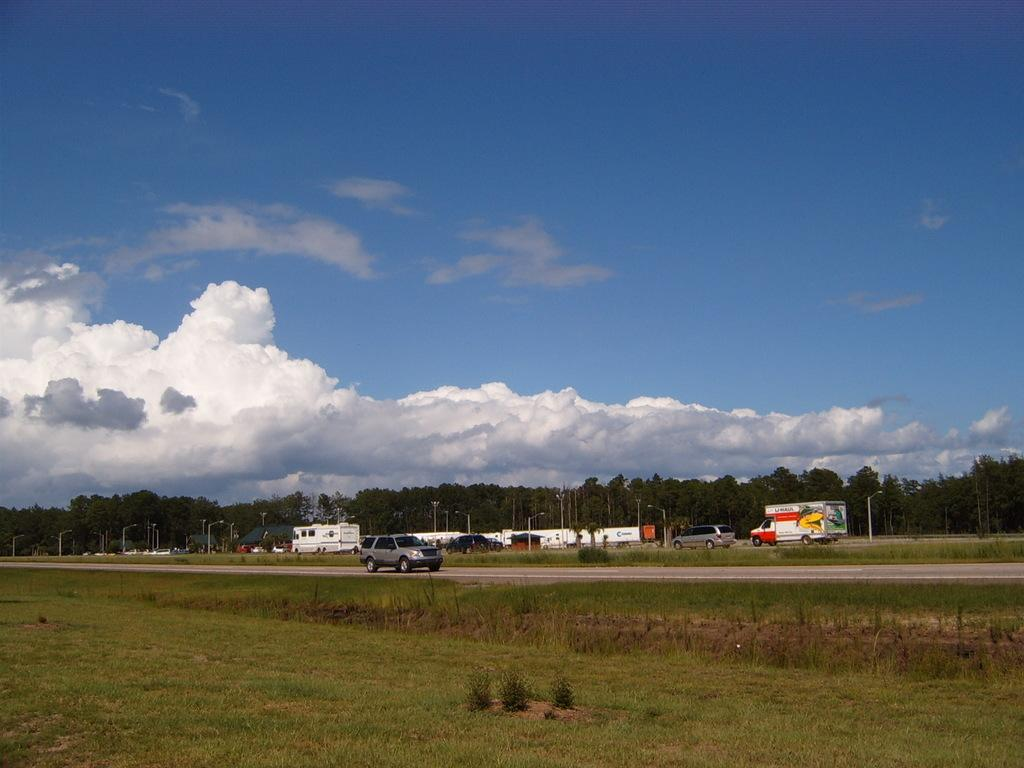What type of ground surface is visible in the image? There is grass on the ground in the image. How would you describe the sky in the image? The sky is blue and cloudy in the image. What type of vegetation can be seen in the image? There are trees visible in the image. What type of man-made objects are present in the image? There are vehicles parked and pole lights in the image. What is happening with the car in the image? A car is moving on the road in the image. Can you hear the person coughing in the image? There is no person coughing in the image, as it is a visual representation and does not include sound. How many people are jumping in the image? There are no people jumping in the image; it only shows a car moving on the road, vehicles parked, and other stationary objects. 